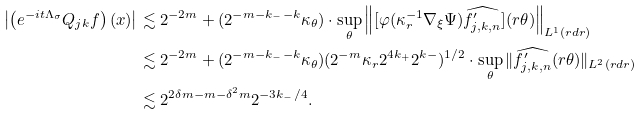Convert formula to latex. <formula><loc_0><loc_0><loc_500><loc_500>\left | \left ( e ^ { - i t \Lambda _ { \sigma } } Q _ { j k } f \right ) ( x ) \right | & \lesssim 2 ^ { - 2 m } + ( 2 ^ { - m - k _ { - } - k } \kappa _ { \theta } ) \cdot \sup _ { \theta } \left \| [ \varphi ( \kappa _ { r } ^ { - 1 } \nabla _ { \xi } \Psi ) \widehat { f ^ { \prime } _ { j , k , n } } ] ( r \theta ) \right \| _ { L ^ { 1 } ( r d r ) } \\ & \lesssim 2 ^ { - 2 m } + ( 2 ^ { - m - k _ { - } - k } \kappa _ { \theta } ) ( 2 ^ { - m } \kappa _ { r } 2 ^ { 4 k _ { + } } 2 ^ { k - } ) ^ { 1 / 2 } \cdot \sup _ { \theta } \| \widehat { f ^ { \prime } _ { j , k , n } } ( r \theta ) \| _ { L ^ { 2 } ( r d r ) } \\ & \lesssim 2 ^ { 2 \delta m - m - \delta ^ { 2 } m } 2 ^ { - 3 k _ { - } / 4 } .</formula> 